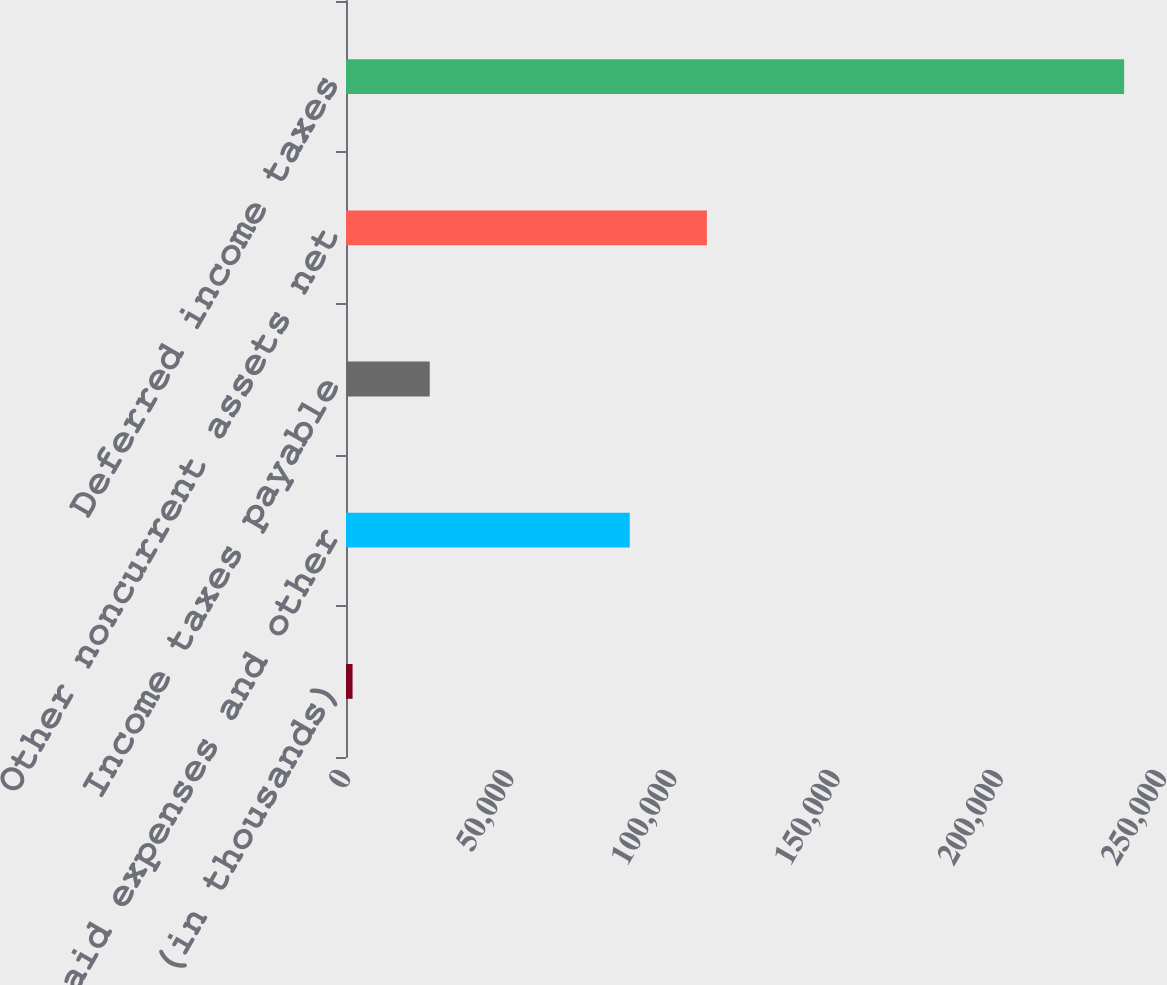<chart> <loc_0><loc_0><loc_500><loc_500><bar_chart><fcel>(in thousands)<fcel>Prepaid expenses and other<fcel>Income taxes payable<fcel>Other noncurrent assets net<fcel>Deferred income taxes<nl><fcel>2013<fcel>86929<fcel>25651.1<fcel>110567<fcel>238394<nl></chart> 